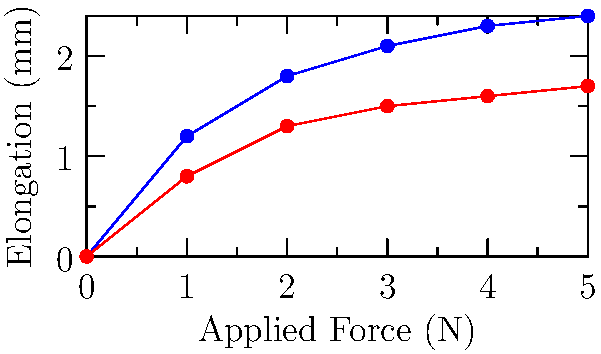The graph shows the force-elongation relationship for a high-end zipper compared to a standard zipper. Based on this data, which mechanical property is most likely improved in the high-end zipper, and how might this affect its failure mode compared to the standard zipper? To answer this question, let's analyze the graph step-by-step:

1. Observe the curves: The blue curve (high-end zipper) shows greater elongation for the same applied force compared to the red curve (standard zipper).

2. Interpret the slopes: The slope of each curve represents the stiffness of the material. A steeper slope indicates higher stiffness.

3. Compare the slopes: The high-end zipper has a lower slope, indicating lower stiffness and higher elasticity.

4. Relate to mechanical properties: Higher elasticity suggests improved flexibility and resilience in the high-end zipper.

5. Consider failure modes:
   a) Standard zipper (higher stiffness): More likely to fail by sudden breaking or teeth separation under high stress.
   b) High-end zipper (higher elasticity): More likely to deform temporarily under stress but return to its original shape, reducing the risk of sudden failure.

6. Luxury fashion context: In high-end fashion items, improved elasticity can provide better comfort, ease of use, and longevity, which are desirable qualities for luxury products.

Therefore, the mechanical property most likely improved in the high-end zipper is elasticity, which can lead to a more gradual and recoverable deformation as its primary failure mode, as opposed to sudden breaking in standard zippers.
Answer: Improved elasticity; gradual, recoverable deformation vs. sudden breaking 